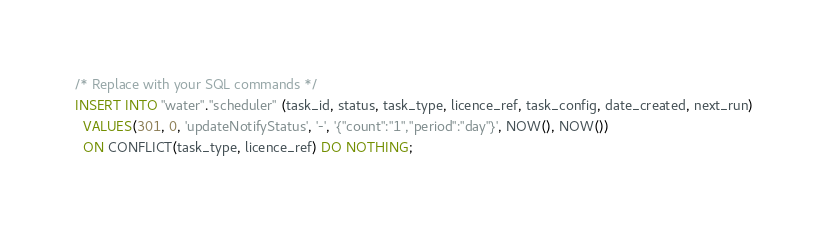Convert code to text. <code><loc_0><loc_0><loc_500><loc_500><_SQL_>/* Replace with your SQL commands */
INSERT INTO "water"."scheduler" (task_id, status, task_type, licence_ref, task_config, date_created, next_run)
  VALUES(301, 0, 'updateNotifyStatus', '-', '{"count":"1","period":"day"}', NOW(), NOW())
  ON CONFLICT(task_type, licence_ref) DO NOTHING;
</code> 